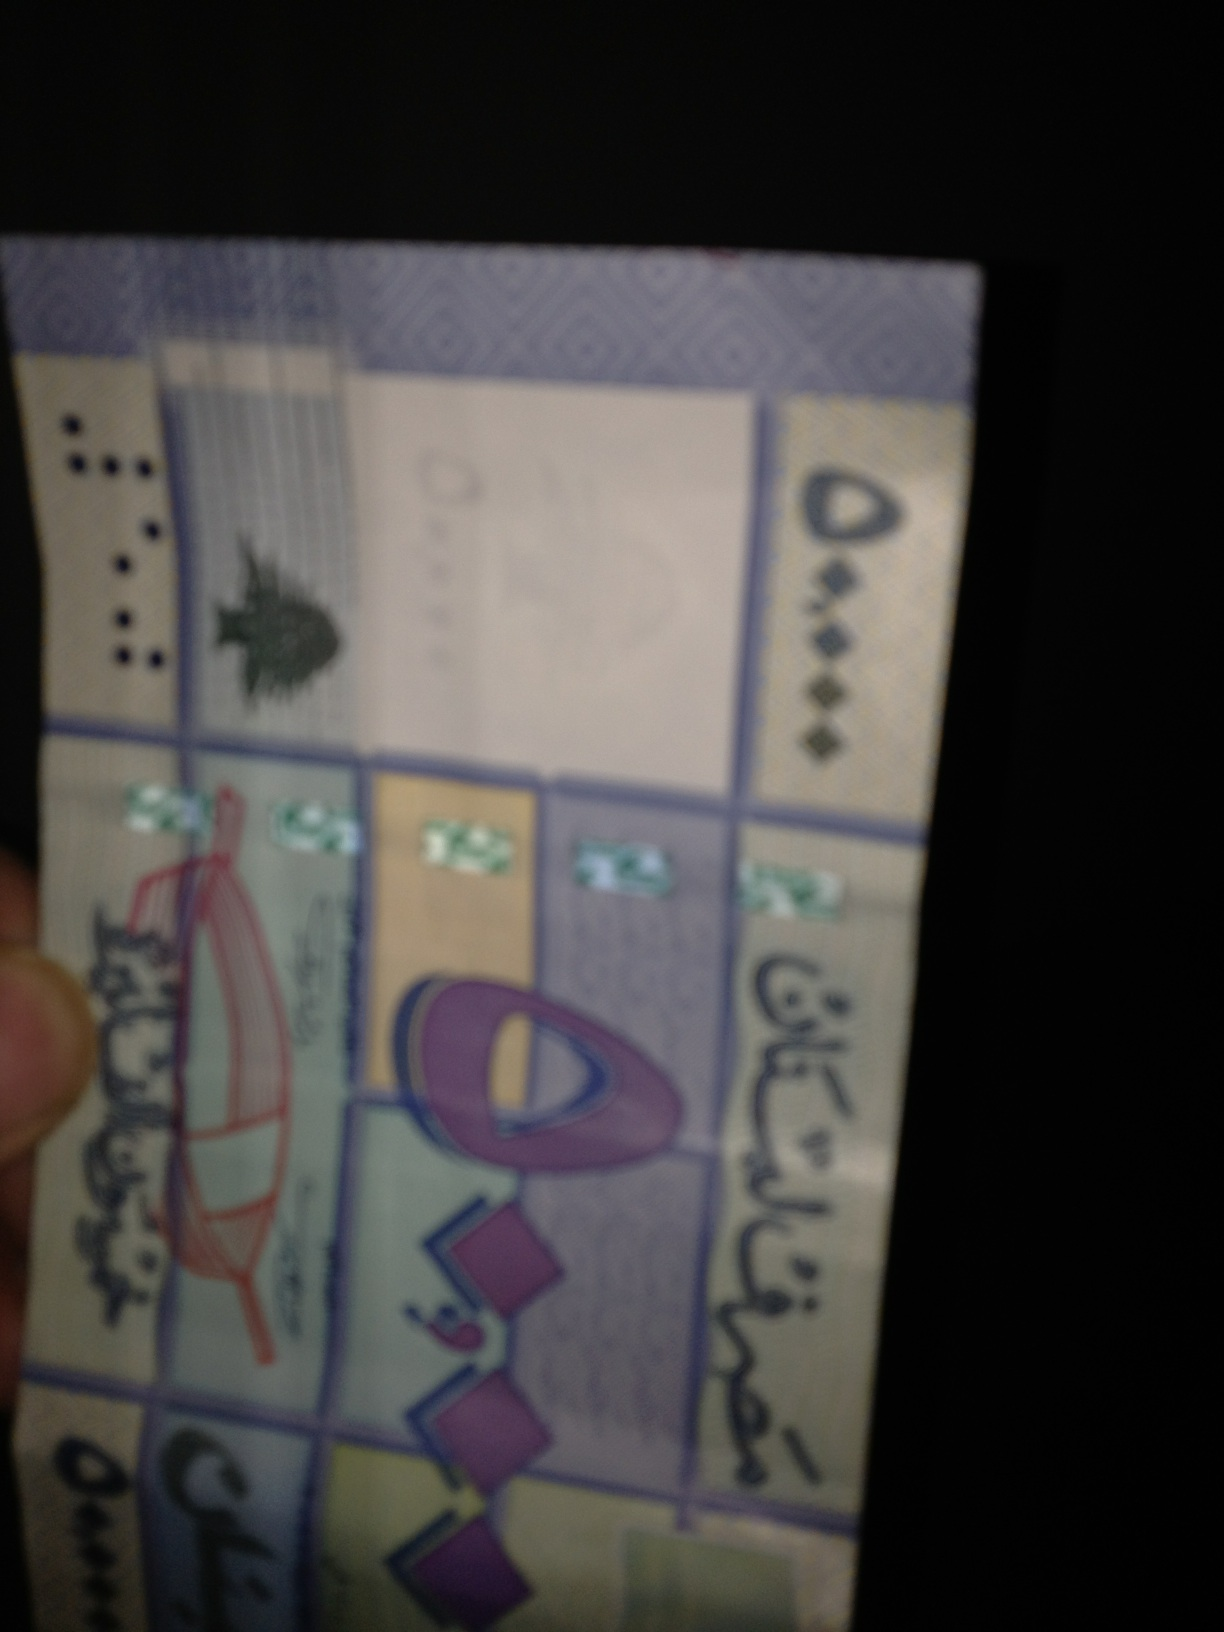What is the sum of this money? Due to the poor image quality and blurring, it's challenging to clearly identify the exact denominations or total sum of the money shown. For a precise answer, a clearer image or additional details would be necessary. 